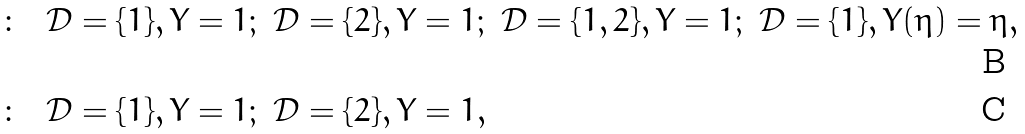Convert formula to latex. <formula><loc_0><loc_0><loc_500><loc_500>\colon \ \ & \mathcal { D } = \{ 1 \} , Y = 1 ; \ \mathcal { D } = \{ 2 \} , Y = 1 ; \ \mathcal { D } = \{ 1 , 2 \} , Y = 1 ; \ \mathcal { D } = \{ 1 \} , Y ( \eta ) = \eta , \\ \colon \ \ & \mathcal { D } = \{ 1 \} , Y = 1 ; \ \mathcal { D } = \{ 2 \} , Y = 1 ,</formula> 